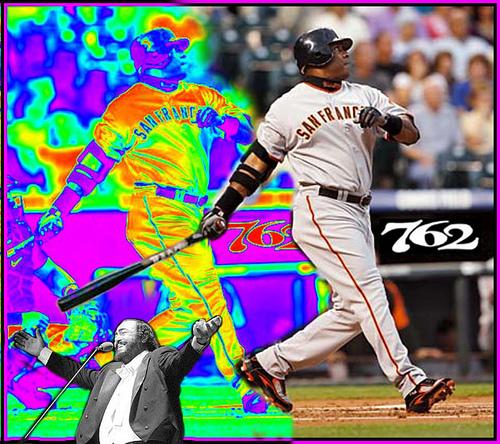Is there a filter on this picture?
Keep it brief. Yes. Is there an opera singer in this photo?
Concise answer only. Yes. What is the singer doing?
Quick response, please. Singing. 